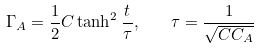Convert formula to latex. <formula><loc_0><loc_0><loc_500><loc_500>\Gamma _ { A } = \frac { 1 } { 2 } C \tanh ^ { 2 } \frac { t } { \tau } , \quad \tau = \frac { 1 } { \sqrt { C C _ { A } } }</formula> 